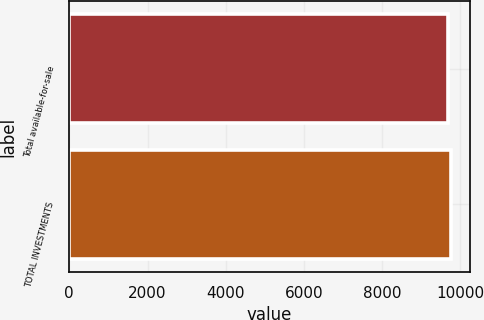Convert chart to OTSL. <chart><loc_0><loc_0><loc_500><loc_500><bar_chart><fcel>Total available-for-sale<fcel>TOTAL INVESTMENTS<nl><fcel>9679<fcel>9758<nl></chart> 